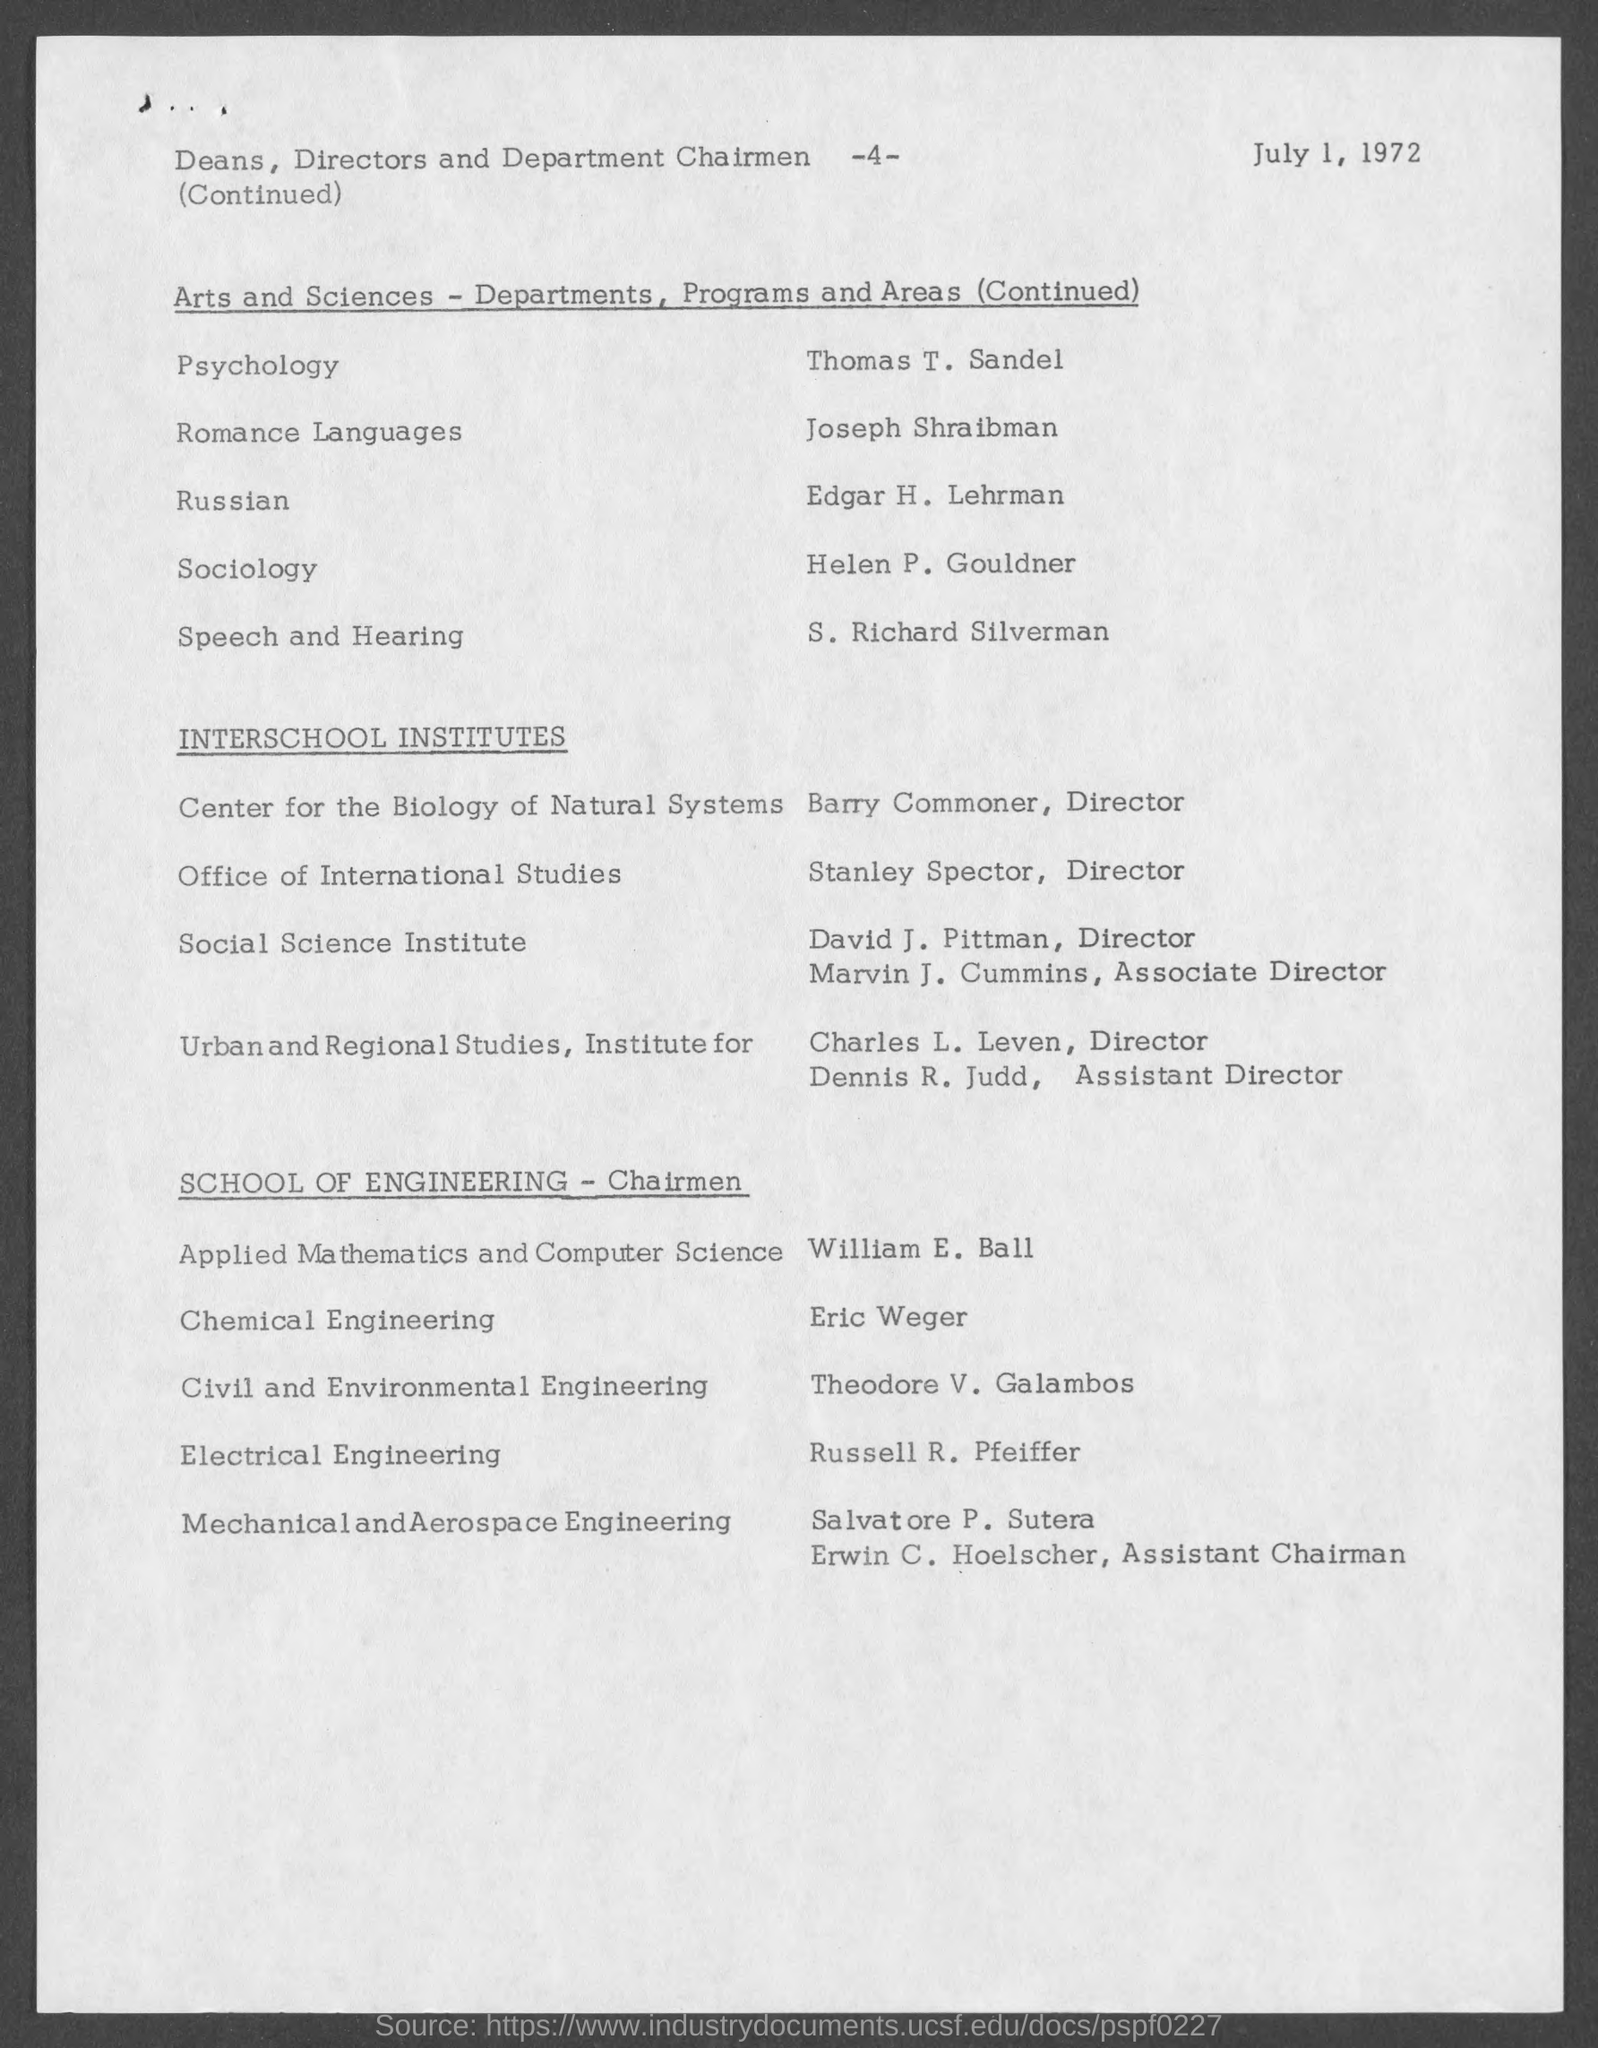Highlight a few significant elements in this photo. The date mentioned in this document is July 1, 1972. Stanley Spector is the Director of the Office of International Studies. The Director of the Center for the Biology of Natural Systems is Barry Commoner. 